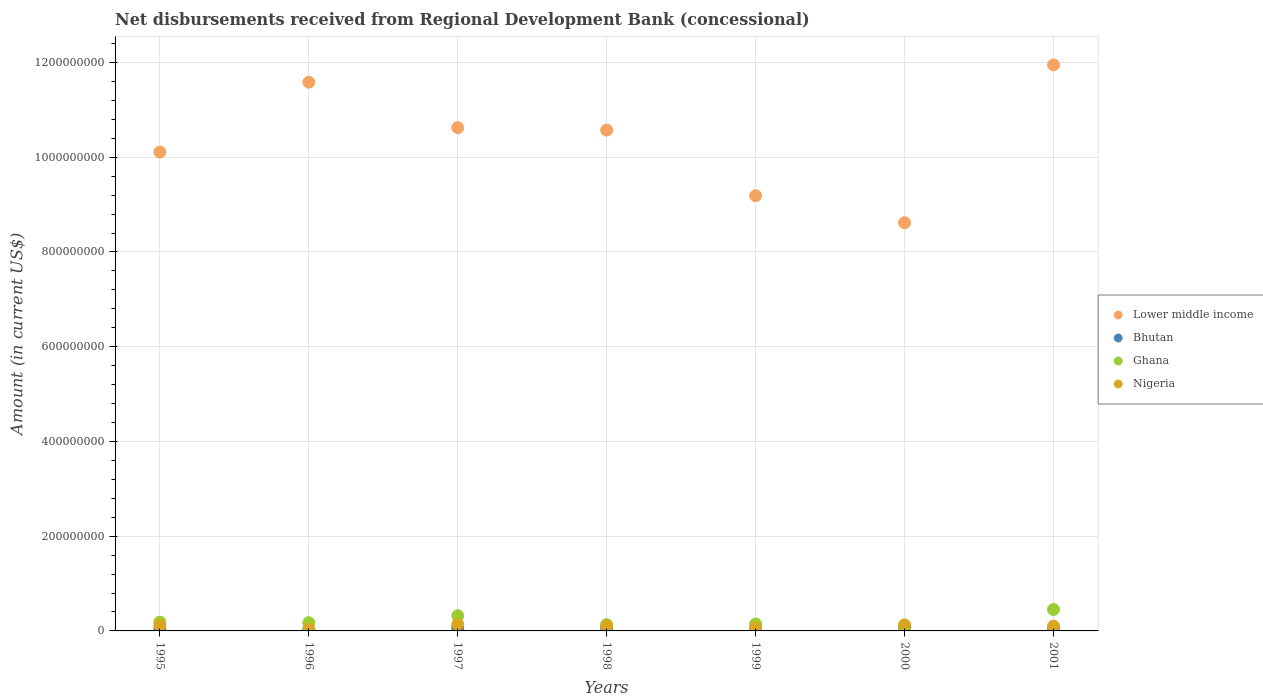How many different coloured dotlines are there?
Make the answer very short. 4. What is the amount of disbursements received from Regional Development Bank in Bhutan in 1998?
Ensure brevity in your answer.  3.78e+06. Across all years, what is the maximum amount of disbursements received from Regional Development Bank in Lower middle income?
Give a very brief answer. 1.20e+09. Across all years, what is the minimum amount of disbursements received from Regional Development Bank in Bhutan?
Your answer should be very brief. 1.33e+06. What is the total amount of disbursements received from Regional Development Bank in Lower middle income in the graph?
Your response must be concise. 7.26e+09. What is the difference between the amount of disbursements received from Regional Development Bank in Ghana in 1995 and that in 2001?
Provide a short and direct response. -2.66e+07. What is the difference between the amount of disbursements received from Regional Development Bank in Ghana in 1995 and the amount of disbursements received from Regional Development Bank in Bhutan in 2001?
Your answer should be very brief. 1.26e+07. What is the average amount of disbursements received from Regional Development Bank in Ghana per year?
Offer a very short reply. 2.03e+07. In the year 1999, what is the difference between the amount of disbursements received from Regional Development Bank in Lower middle income and amount of disbursements received from Regional Development Bank in Nigeria?
Your response must be concise. 9.12e+08. In how many years, is the amount of disbursements received from Regional Development Bank in Nigeria greater than 280000000 US$?
Give a very brief answer. 0. What is the ratio of the amount of disbursements received from Regional Development Bank in Lower middle income in 1997 to that in 1998?
Your response must be concise. 1. What is the difference between the highest and the second highest amount of disbursements received from Regional Development Bank in Lower middle income?
Keep it short and to the point. 3.65e+07. What is the difference between the highest and the lowest amount of disbursements received from Regional Development Bank in Bhutan?
Give a very brief answer. 5.35e+06. In how many years, is the amount of disbursements received from Regional Development Bank in Bhutan greater than the average amount of disbursements received from Regional Development Bank in Bhutan taken over all years?
Your response must be concise. 3. Is the amount of disbursements received from Regional Development Bank in Lower middle income strictly greater than the amount of disbursements received from Regional Development Bank in Ghana over the years?
Offer a terse response. Yes. Does the graph contain grids?
Your response must be concise. Yes. Where does the legend appear in the graph?
Your answer should be compact. Center right. What is the title of the graph?
Keep it short and to the point. Net disbursements received from Regional Development Bank (concessional). Does "Bhutan" appear as one of the legend labels in the graph?
Keep it short and to the point. Yes. What is the label or title of the X-axis?
Give a very brief answer. Years. What is the Amount (in current US$) in Lower middle income in 1995?
Make the answer very short. 1.01e+09. What is the Amount (in current US$) in Bhutan in 1995?
Offer a terse response. 3.21e+06. What is the Amount (in current US$) in Ghana in 1995?
Give a very brief answer. 1.87e+07. What is the Amount (in current US$) in Nigeria in 1995?
Provide a succinct answer. 1.16e+07. What is the Amount (in current US$) of Lower middle income in 1996?
Provide a succinct answer. 1.16e+09. What is the Amount (in current US$) of Bhutan in 1996?
Make the answer very short. 2.41e+06. What is the Amount (in current US$) in Ghana in 1996?
Provide a short and direct response. 1.74e+07. What is the Amount (in current US$) of Nigeria in 1996?
Provide a short and direct response. 3.98e+06. What is the Amount (in current US$) in Lower middle income in 1997?
Your answer should be compact. 1.06e+09. What is the Amount (in current US$) of Bhutan in 1997?
Offer a terse response. 6.68e+06. What is the Amount (in current US$) of Ghana in 1997?
Ensure brevity in your answer.  3.21e+07. What is the Amount (in current US$) of Nigeria in 1997?
Offer a very short reply. 1.39e+07. What is the Amount (in current US$) in Lower middle income in 1998?
Provide a succinct answer. 1.06e+09. What is the Amount (in current US$) in Bhutan in 1998?
Make the answer very short. 3.78e+06. What is the Amount (in current US$) of Ghana in 1998?
Make the answer very short. 1.32e+07. What is the Amount (in current US$) of Nigeria in 1998?
Provide a succinct answer. 9.97e+06. What is the Amount (in current US$) of Lower middle income in 1999?
Offer a very short reply. 9.19e+08. What is the Amount (in current US$) in Bhutan in 1999?
Your answer should be compact. 1.33e+06. What is the Amount (in current US$) of Ghana in 1999?
Provide a succinct answer. 1.46e+07. What is the Amount (in current US$) in Nigeria in 1999?
Give a very brief answer. 6.28e+06. What is the Amount (in current US$) in Lower middle income in 2000?
Offer a terse response. 8.62e+08. What is the Amount (in current US$) in Bhutan in 2000?
Offer a very short reply. 6.14e+06. What is the Amount (in current US$) of Ghana in 2000?
Your answer should be very brief. 7.06e+05. What is the Amount (in current US$) of Nigeria in 2000?
Give a very brief answer. 1.27e+07. What is the Amount (in current US$) of Lower middle income in 2001?
Give a very brief answer. 1.20e+09. What is the Amount (in current US$) in Bhutan in 2001?
Your answer should be compact. 6.04e+06. What is the Amount (in current US$) of Ghana in 2001?
Give a very brief answer. 4.53e+07. What is the Amount (in current US$) of Nigeria in 2001?
Your answer should be very brief. 1.01e+07. Across all years, what is the maximum Amount (in current US$) of Lower middle income?
Offer a terse response. 1.20e+09. Across all years, what is the maximum Amount (in current US$) of Bhutan?
Your answer should be compact. 6.68e+06. Across all years, what is the maximum Amount (in current US$) in Ghana?
Offer a very short reply. 4.53e+07. Across all years, what is the maximum Amount (in current US$) in Nigeria?
Ensure brevity in your answer.  1.39e+07. Across all years, what is the minimum Amount (in current US$) in Lower middle income?
Provide a short and direct response. 8.62e+08. Across all years, what is the minimum Amount (in current US$) in Bhutan?
Make the answer very short. 1.33e+06. Across all years, what is the minimum Amount (in current US$) in Ghana?
Offer a terse response. 7.06e+05. Across all years, what is the minimum Amount (in current US$) of Nigeria?
Provide a succinct answer. 3.98e+06. What is the total Amount (in current US$) of Lower middle income in the graph?
Your answer should be very brief. 7.26e+09. What is the total Amount (in current US$) in Bhutan in the graph?
Keep it short and to the point. 2.96e+07. What is the total Amount (in current US$) in Ghana in the graph?
Offer a terse response. 1.42e+08. What is the total Amount (in current US$) of Nigeria in the graph?
Your answer should be compact. 6.86e+07. What is the difference between the Amount (in current US$) in Lower middle income in 1995 and that in 1996?
Provide a short and direct response. -1.47e+08. What is the difference between the Amount (in current US$) in Ghana in 1995 and that in 1996?
Provide a short and direct response. 1.25e+06. What is the difference between the Amount (in current US$) in Nigeria in 1995 and that in 1996?
Ensure brevity in your answer.  7.66e+06. What is the difference between the Amount (in current US$) of Lower middle income in 1995 and that in 1997?
Ensure brevity in your answer.  -5.14e+07. What is the difference between the Amount (in current US$) of Bhutan in 1995 and that in 1997?
Ensure brevity in your answer.  -3.47e+06. What is the difference between the Amount (in current US$) of Ghana in 1995 and that in 1997?
Offer a very short reply. -1.34e+07. What is the difference between the Amount (in current US$) in Nigeria in 1995 and that in 1997?
Give a very brief answer. -2.25e+06. What is the difference between the Amount (in current US$) in Lower middle income in 1995 and that in 1998?
Keep it short and to the point. -4.63e+07. What is the difference between the Amount (in current US$) in Bhutan in 1995 and that in 1998?
Your response must be concise. -5.66e+05. What is the difference between the Amount (in current US$) in Ghana in 1995 and that in 1998?
Offer a very short reply. 5.48e+06. What is the difference between the Amount (in current US$) of Nigeria in 1995 and that in 1998?
Your answer should be compact. 1.67e+06. What is the difference between the Amount (in current US$) of Lower middle income in 1995 and that in 1999?
Make the answer very short. 9.23e+07. What is the difference between the Amount (in current US$) in Bhutan in 1995 and that in 1999?
Offer a terse response. 1.88e+06. What is the difference between the Amount (in current US$) of Ghana in 1995 and that in 1999?
Provide a succinct answer. 4.10e+06. What is the difference between the Amount (in current US$) of Nigeria in 1995 and that in 1999?
Provide a succinct answer. 5.37e+06. What is the difference between the Amount (in current US$) in Lower middle income in 1995 and that in 2000?
Offer a terse response. 1.49e+08. What is the difference between the Amount (in current US$) in Bhutan in 1995 and that in 2000?
Keep it short and to the point. -2.93e+06. What is the difference between the Amount (in current US$) in Ghana in 1995 and that in 2000?
Provide a succinct answer. 1.80e+07. What is the difference between the Amount (in current US$) in Nigeria in 1995 and that in 2000?
Ensure brevity in your answer.  -1.09e+06. What is the difference between the Amount (in current US$) of Lower middle income in 1995 and that in 2001?
Offer a terse response. -1.84e+08. What is the difference between the Amount (in current US$) of Bhutan in 1995 and that in 2001?
Your response must be concise. -2.83e+06. What is the difference between the Amount (in current US$) in Ghana in 1995 and that in 2001?
Your response must be concise. -2.66e+07. What is the difference between the Amount (in current US$) of Nigeria in 1995 and that in 2001?
Offer a terse response. 1.52e+06. What is the difference between the Amount (in current US$) of Lower middle income in 1996 and that in 1997?
Provide a short and direct response. 9.60e+07. What is the difference between the Amount (in current US$) of Bhutan in 1996 and that in 1997?
Offer a very short reply. -4.27e+06. What is the difference between the Amount (in current US$) in Ghana in 1996 and that in 1997?
Give a very brief answer. -1.47e+07. What is the difference between the Amount (in current US$) of Nigeria in 1996 and that in 1997?
Make the answer very short. -9.91e+06. What is the difference between the Amount (in current US$) of Lower middle income in 1996 and that in 1998?
Your response must be concise. 1.01e+08. What is the difference between the Amount (in current US$) in Bhutan in 1996 and that in 1998?
Make the answer very short. -1.37e+06. What is the difference between the Amount (in current US$) in Ghana in 1996 and that in 1998?
Your response must be concise. 4.23e+06. What is the difference between the Amount (in current US$) of Nigeria in 1996 and that in 1998?
Your answer should be very brief. -5.99e+06. What is the difference between the Amount (in current US$) in Lower middle income in 1996 and that in 1999?
Provide a short and direct response. 2.40e+08. What is the difference between the Amount (in current US$) of Bhutan in 1996 and that in 1999?
Offer a very short reply. 1.08e+06. What is the difference between the Amount (in current US$) in Ghana in 1996 and that in 1999?
Give a very brief answer. 2.84e+06. What is the difference between the Amount (in current US$) of Nigeria in 1996 and that in 1999?
Offer a very short reply. -2.29e+06. What is the difference between the Amount (in current US$) in Lower middle income in 1996 and that in 2000?
Make the answer very short. 2.97e+08. What is the difference between the Amount (in current US$) in Bhutan in 1996 and that in 2000?
Ensure brevity in your answer.  -3.73e+06. What is the difference between the Amount (in current US$) in Ghana in 1996 and that in 2000?
Give a very brief answer. 1.67e+07. What is the difference between the Amount (in current US$) of Nigeria in 1996 and that in 2000?
Ensure brevity in your answer.  -8.75e+06. What is the difference between the Amount (in current US$) of Lower middle income in 1996 and that in 2001?
Keep it short and to the point. -3.65e+07. What is the difference between the Amount (in current US$) in Bhutan in 1996 and that in 2001?
Your response must be concise. -3.63e+06. What is the difference between the Amount (in current US$) of Ghana in 1996 and that in 2001?
Ensure brevity in your answer.  -2.79e+07. What is the difference between the Amount (in current US$) in Nigeria in 1996 and that in 2001?
Keep it short and to the point. -6.13e+06. What is the difference between the Amount (in current US$) of Lower middle income in 1997 and that in 1998?
Ensure brevity in your answer.  5.16e+06. What is the difference between the Amount (in current US$) in Bhutan in 1997 and that in 1998?
Your response must be concise. 2.90e+06. What is the difference between the Amount (in current US$) in Ghana in 1997 and that in 1998?
Give a very brief answer. 1.89e+07. What is the difference between the Amount (in current US$) in Nigeria in 1997 and that in 1998?
Offer a very short reply. 3.92e+06. What is the difference between the Amount (in current US$) of Lower middle income in 1997 and that in 1999?
Your answer should be compact. 1.44e+08. What is the difference between the Amount (in current US$) in Bhutan in 1997 and that in 1999?
Offer a terse response. 5.35e+06. What is the difference between the Amount (in current US$) of Ghana in 1997 and that in 1999?
Keep it short and to the point. 1.75e+07. What is the difference between the Amount (in current US$) of Nigeria in 1997 and that in 1999?
Make the answer very short. 7.62e+06. What is the difference between the Amount (in current US$) of Lower middle income in 1997 and that in 2000?
Make the answer very short. 2.01e+08. What is the difference between the Amount (in current US$) in Bhutan in 1997 and that in 2000?
Your response must be concise. 5.43e+05. What is the difference between the Amount (in current US$) in Ghana in 1997 and that in 2000?
Give a very brief answer. 3.14e+07. What is the difference between the Amount (in current US$) of Nigeria in 1997 and that in 2000?
Your answer should be very brief. 1.16e+06. What is the difference between the Amount (in current US$) of Lower middle income in 1997 and that in 2001?
Offer a very short reply. -1.33e+08. What is the difference between the Amount (in current US$) of Bhutan in 1997 and that in 2001?
Provide a succinct answer. 6.40e+05. What is the difference between the Amount (in current US$) in Ghana in 1997 and that in 2001?
Your answer should be compact. -1.32e+07. What is the difference between the Amount (in current US$) of Nigeria in 1997 and that in 2001?
Give a very brief answer. 3.78e+06. What is the difference between the Amount (in current US$) of Lower middle income in 1998 and that in 1999?
Offer a terse response. 1.39e+08. What is the difference between the Amount (in current US$) of Bhutan in 1998 and that in 1999?
Keep it short and to the point. 2.45e+06. What is the difference between the Amount (in current US$) of Ghana in 1998 and that in 1999?
Give a very brief answer. -1.38e+06. What is the difference between the Amount (in current US$) in Nigeria in 1998 and that in 1999?
Your answer should be compact. 3.70e+06. What is the difference between the Amount (in current US$) of Lower middle income in 1998 and that in 2000?
Offer a very short reply. 1.96e+08. What is the difference between the Amount (in current US$) of Bhutan in 1998 and that in 2000?
Offer a very short reply. -2.36e+06. What is the difference between the Amount (in current US$) of Ghana in 1998 and that in 2000?
Give a very brief answer. 1.25e+07. What is the difference between the Amount (in current US$) in Nigeria in 1998 and that in 2000?
Provide a succinct answer. -2.76e+06. What is the difference between the Amount (in current US$) of Lower middle income in 1998 and that in 2001?
Provide a succinct answer. -1.38e+08. What is the difference between the Amount (in current US$) in Bhutan in 1998 and that in 2001?
Your answer should be compact. -2.26e+06. What is the difference between the Amount (in current US$) in Ghana in 1998 and that in 2001?
Give a very brief answer. -3.21e+07. What is the difference between the Amount (in current US$) of Nigeria in 1998 and that in 2001?
Your answer should be compact. -1.47e+05. What is the difference between the Amount (in current US$) of Lower middle income in 1999 and that in 2000?
Provide a short and direct response. 5.71e+07. What is the difference between the Amount (in current US$) of Bhutan in 1999 and that in 2000?
Make the answer very short. -4.81e+06. What is the difference between the Amount (in current US$) of Ghana in 1999 and that in 2000?
Give a very brief answer. 1.39e+07. What is the difference between the Amount (in current US$) of Nigeria in 1999 and that in 2000?
Your answer should be very brief. -6.46e+06. What is the difference between the Amount (in current US$) of Lower middle income in 1999 and that in 2001?
Your response must be concise. -2.76e+08. What is the difference between the Amount (in current US$) of Bhutan in 1999 and that in 2001?
Provide a succinct answer. -4.71e+06. What is the difference between the Amount (in current US$) of Ghana in 1999 and that in 2001?
Offer a very short reply. -3.07e+07. What is the difference between the Amount (in current US$) of Nigeria in 1999 and that in 2001?
Ensure brevity in your answer.  -3.84e+06. What is the difference between the Amount (in current US$) in Lower middle income in 2000 and that in 2001?
Keep it short and to the point. -3.33e+08. What is the difference between the Amount (in current US$) in Bhutan in 2000 and that in 2001?
Keep it short and to the point. 9.70e+04. What is the difference between the Amount (in current US$) in Ghana in 2000 and that in 2001?
Offer a very short reply. -4.46e+07. What is the difference between the Amount (in current US$) of Nigeria in 2000 and that in 2001?
Your answer should be compact. 2.62e+06. What is the difference between the Amount (in current US$) of Lower middle income in 1995 and the Amount (in current US$) of Bhutan in 1996?
Provide a short and direct response. 1.01e+09. What is the difference between the Amount (in current US$) of Lower middle income in 1995 and the Amount (in current US$) of Ghana in 1996?
Provide a short and direct response. 9.94e+08. What is the difference between the Amount (in current US$) of Lower middle income in 1995 and the Amount (in current US$) of Nigeria in 1996?
Provide a short and direct response. 1.01e+09. What is the difference between the Amount (in current US$) in Bhutan in 1995 and the Amount (in current US$) in Ghana in 1996?
Your answer should be compact. -1.42e+07. What is the difference between the Amount (in current US$) of Bhutan in 1995 and the Amount (in current US$) of Nigeria in 1996?
Provide a succinct answer. -7.71e+05. What is the difference between the Amount (in current US$) in Ghana in 1995 and the Amount (in current US$) in Nigeria in 1996?
Give a very brief answer. 1.47e+07. What is the difference between the Amount (in current US$) in Lower middle income in 1995 and the Amount (in current US$) in Bhutan in 1997?
Keep it short and to the point. 1.00e+09. What is the difference between the Amount (in current US$) in Lower middle income in 1995 and the Amount (in current US$) in Ghana in 1997?
Keep it short and to the point. 9.79e+08. What is the difference between the Amount (in current US$) of Lower middle income in 1995 and the Amount (in current US$) of Nigeria in 1997?
Your response must be concise. 9.97e+08. What is the difference between the Amount (in current US$) of Bhutan in 1995 and the Amount (in current US$) of Ghana in 1997?
Your answer should be very brief. -2.89e+07. What is the difference between the Amount (in current US$) of Bhutan in 1995 and the Amount (in current US$) of Nigeria in 1997?
Make the answer very short. -1.07e+07. What is the difference between the Amount (in current US$) in Ghana in 1995 and the Amount (in current US$) in Nigeria in 1997?
Make the answer very short. 4.76e+06. What is the difference between the Amount (in current US$) in Lower middle income in 1995 and the Amount (in current US$) in Bhutan in 1998?
Provide a succinct answer. 1.01e+09. What is the difference between the Amount (in current US$) of Lower middle income in 1995 and the Amount (in current US$) of Ghana in 1998?
Give a very brief answer. 9.98e+08. What is the difference between the Amount (in current US$) of Lower middle income in 1995 and the Amount (in current US$) of Nigeria in 1998?
Give a very brief answer. 1.00e+09. What is the difference between the Amount (in current US$) in Bhutan in 1995 and the Amount (in current US$) in Ghana in 1998?
Give a very brief answer. -9.96e+06. What is the difference between the Amount (in current US$) of Bhutan in 1995 and the Amount (in current US$) of Nigeria in 1998?
Ensure brevity in your answer.  -6.76e+06. What is the difference between the Amount (in current US$) in Ghana in 1995 and the Amount (in current US$) in Nigeria in 1998?
Your response must be concise. 8.69e+06. What is the difference between the Amount (in current US$) of Lower middle income in 1995 and the Amount (in current US$) of Bhutan in 1999?
Offer a terse response. 1.01e+09. What is the difference between the Amount (in current US$) in Lower middle income in 1995 and the Amount (in current US$) in Ghana in 1999?
Make the answer very short. 9.96e+08. What is the difference between the Amount (in current US$) in Lower middle income in 1995 and the Amount (in current US$) in Nigeria in 1999?
Your response must be concise. 1.00e+09. What is the difference between the Amount (in current US$) in Bhutan in 1995 and the Amount (in current US$) in Ghana in 1999?
Your response must be concise. -1.13e+07. What is the difference between the Amount (in current US$) of Bhutan in 1995 and the Amount (in current US$) of Nigeria in 1999?
Provide a succinct answer. -3.06e+06. What is the difference between the Amount (in current US$) of Ghana in 1995 and the Amount (in current US$) of Nigeria in 1999?
Keep it short and to the point. 1.24e+07. What is the difference between the Amount (in current US$) of Lower middle income in 1995 and the Amount (in current US$) of Bhutan in 2000?
Make the answer very short. 1.00e+09. What is the difference between the Amount (in current US$) in Lower middle income in 1995 and the Amount (in current US$) in Ghana in 2000?
Give a very brief answer. 1.01e+09. What is the difference between the Amount (in current US$) in Lower middle income in 1995 and the Amount (in current US$) in Nigeria in 2000?
Provide a succinct answer. 9.98e+08. What is the difference between the Amount (in current US$) of Bhutan in 1995 and the Amount (in current US$) of Ghana in 2000?
Your answer should be compact. 2.51e+06. What is the difference between the Amount (in current US$) of Bhutan in 1995 and the Amount (in current US$) of Nigeria in 2000?
Provide a short and direct response. -9.52e+06. What is the difference between the Amount (in current US$) of Ghana in 1995 and the Amount (in current US$) of Nigeria in 2000?
Keep it short and to the point. 5.92e+06. What is the difference between the Amount (in current US$) in Lower middle income in 1995 and the Amount (in current US$) in Bhutan in 2001?
Keep it short and to the point. 1.00e+09. What is the difference between the Amount (in current US$) of Lower middle income in 1995 and the Amount (in current US$) of Ghana in 2001?
Give a very brief answer. 9.66e+08. What is the difference between the Amount (in current US$) in Lower middle income in 1995 and the Amount (in current US$) in Nigeria in 2001?
Make the answer very short. 1.00e+09. What is the difference between the Amount (in current US$) in Bhutan in 1995 and the Amount (in current US$) in Ghana in 2001?
Keep it short and to the point. -4.21e+07. What is the difference between the Amount (in current US$) of Bhutan in 1995 and the Amount (in current US$) of Nigeria in 2001?
Give a very brief answer. -6.90e+06. What is the difference between the Amount (in current US$) in Ghana in 1995 and the Amount (in current US$) in Nigeria in 2001?
Your response must be concise. 8.54e+06. What is the difference between the Amount (in current US$) in Lower middle income in 1996 and the Amount (in current US$) in Bhutan in 1997?
Ensure brevity in your answer.  1.15e+09. What is the difference between the Amount (in current US$) in Lower middle income in 1996 and the Amount (in current US$) in Ghana in 1997?
Your response must be concise. 1.13e+09. What is the difference between the Amount (in current US$) in Lower middle income in 1996 and the Amount (in current US$) in Nigeria in 1997?
Make the answer very short. 1.14e+09. What is the difference between the Amount (in current US$) of Bhutan in 1996 and the Amount (in current US$) of Ghana in 1997?
Give a very brief answer. -2.97e+07. What is the difference between the Amount (in current US$) of Bhutan in 1996 and the Amount (in current US$) of Nigeria in 1997?
Give a very brief answer. -1.15e+07. What is the difference between the Amount (in current US$) in Ghana in 1996 and the Amount (in current US$) in Nigeria in 1997?
Give a very brief answer. 3.51e+06. What is the difference between the Amount (in current US$) of Lower middle income in 1996 and the Amount (in current US$) of Bhutan in 1998?
Your answer should be very brief. 1.15e+09. What is the difference between the Amount (in current US$) in Lower middle income in 1996 and the Amount (in current US$) in Ghana in 1998?
Offer a very short reply. 1.15e+09. What is the difference between the Amount (in current US$) in Lower middle income in 1996 and the Amount (in current US$) in Nigeria in 1998?
Provide a short and direct response. 1.15e+09. What is the difference between the Amount (in current US$) in Bhutan in 1996 and the Amount (in current US$) in Ghana in 1998?
Provide a succinct answer. -1.08e+07. What is the difference between the Amount (in current US$) in Bhutan in 1996 and the Amount (in current US$) in Nigeria in 1998?
Offer a terse response. -7.56e+06. What is the difference between the Amount (in current US$) in Ghana in 1996 and the Amount (in current US$) in Nigeria in 1998?
Provide a short and direct response. 7.43e+06. What is the difference between the Amount (in current US$) of Lower middle income in 1996 and the Amount (in current US$) of Bhutan in 1999?
Give a very brief answer. 1.16e+09. What is the difference between the Amount (in current US$) of Lower middle income in 1996 and the Amount (in current US$) of Ghana in 1999?
Offer a terse response. 1.14e+09. What is the difference between the Amount (in current US$) in Lower middle income in 1996 and the Amount (in current US$) in Nigeria in 1999?
Make the answer very short. 1.15e+09. What is the difference between the Amount (in current US$) of Bhutan in 1996 and the Amount (in current US$) of Ghana in 1999?
Give a very brief answer. -1.21e+07. What is the difference between the Amount (in current US$) of Bhutan in 1996 and the Amount (in current US$) of Nigeria in 1999?
Your answer should be very brief. -3.86e+06. What is the difference between the Amount (in current US$) in Ghana in 1996 and the Amount (in current US$) in Nigeria in 1999?
Give a very brief answer. 1.11e+07. What is the difference between the Amount (in current US$) in Lower middle income in 1996 and the Amount (in current US$) in Bhutan in 2000?
Make the answer very short. 1.15e+09. What is the difference between the Amount (in current US$) in Lower middle income in 1996 and the Amount (in current US$) in Ghana in 2000?
Provide a succinct answer. 1.16e+09. What is the difference between the Amount (in current US$) in Lower middle income in 1996 and the Amount (in current US$) in Nigeria in 2000?
Your answer should be compact. 1.15e+09. What is the difference between the Amount (in current US$) in Bhutan in 1996 and the Amount (in current US$) in Ghana in 2000?
Offer a very short reply. 1.71e+06. What is the difference between the Amount (in current US$) of Bhutan in 1996 and the Amount (in current US$) of Nigeria in 2000?
Your response must be concise. -1.03e+07. What is the difference between the Amount (in current US$) in Ghana in 1996 and the Amount (in current US$) in Nigeria in 2000?
Your answer should be very brief. 4.67e+06. What is the difference between the Amount (in current US$) of Lower middle income in 1996 and the Amount (in current US$) of Bhutan in 2001?
Your answer should be compact. 1.15e+09. What is the difference between the Amount (in current US$) of Lower middle income in 1996 and the Amount (in current US$) of Ghana in 2001?
Provide a short and direct response. 1.11e+09. What is the difference between the Amount (in current US$) in Lower middle income in 1996 and the Amount (in current US$) in Nigeria in 2001?
Ensure brevity in your answer.  1.15e+09. What is the difference between the Amount (in current US$) in Bhutan in 1996 and the Amount (in current US$) in Ghana in 2001?
Provide a short and direct response. -4.29e+07. What is the difference between the Amount (in current US$) of Bhutan in 1996 and the Amount (in current US$) of Nigeria in 2001?
Your response must be concise. -7.70e+06. What is the difference between the Amount (in current US$) of Ghana in 1996 and the Amount (in current US$) of Nigeria in 2001?
Give a very brief answer. 7.29e+06. What is the difference between the Amount (in current US$) of Lower middle income in 1997 and the Amount (in current US$) of Bhutan in 1998?
Provide a succinct answer. 1.06e+09. What is the difference between the Amount (in current US$) of Lower middle income in 1997 and the Amount (in current US$) of Ghana in 1998?
Keep it short and to the point. 1.05e+09. What is the difference between the Amount (in current US$) in Lower middle income in 1997 and the Amount (in current US$) in Nigeria in 1998?
Ensure brevity in your answer.  1.05e+09. What is the difference between the Amount (in current US$) of Bhutan in 1997 and the Amount (in current US$) of Ghana in 1998?
Give a very brief answer. -6.49e+06. What is the difference between the Amount (in current US$) of Bhutan in 1997 and the Amount (in current US$) of Nigeria in 1998?
Make the answer very short. -3.29e+06. What is the difference between the Amount (in current US$) of Ghana in 1997 and the Amount (in current US$) of Nigeria in 1998?
Offer a terse response. 2.21e+07. What is the difference between the Amount (in current US$) of Lower middle income in 1997 and the Amount (in current US$) of Bhutan in 1999?
Your answer should be very brief. 1.06e+09. What is the difference between the Amount (in current US$) of Lower middle income in 1997 and the Amount (in current US$) of Ghana in 1999?
Provide a short and direct response. 1.05e+09. What is the difference between the Amount (in current US$) of Lower middle income in 1997 and the Amount (in current US$) of Nigeria in 1999?
Offer a terse response. 1.06e+09. What is the difference between the Amount (in current US$) of Bhutan in 1997 and the Amount (in current US$) of Ghana in 1999?
Offer a terse response. -7.88e+06. What is the difference between the Amount (in current US$) in Bhutan in 1997 and the Amount (in current US$) in Nigeria in 1999?
Provide a succinct answer. 4.06e+05. What is the difference between the Amount (in current US$) in Ghana in 1997 and the Amount (in current US$) in Nigeria in 1999?
Your answer should be compact. 2.58e+07. What is the difference between the Amount (in current US$) in Lower middle income in 1997 and the Amount (in current US$) in Bhutan in 2000?
Offer a very short reply. 1.06e+09. What is the difference between the Amount (in current US$) of Lower middle income in 1997 and the Amount (in current US$) of Ghana in 2000?
Keep it short and to the point. 1.06e+09. What is the difference between the Amount (in current US$) of Lower middle income in 1997 and the Amount (in current US$) of Nigeria in 2000?
Ensure brevity in your answer.  1.05e+09. What is the difference between the Amount (in current US$) of Bhutan in 1997 and the Amount (in current US$) of Ghana in 2000?
Keep it short and to the point. 5.98e+06. What is the difference between the Amount (in current US$) of Bhutan in 1997 and the Amount (in current US$) of Nigeria in 2000?
Offer a very short reply. -6.05e+06. What is the difference between the Amount (in current US$) in Ghana in 1997 and the Amount (in current US$) in Nigeria in 2000?
Ensure brevity in your answer.  1.93e+07. What is the difference between the Amount (in current US$) of Lower middle income in 1997 and the Amount (in current US$) of Bhutan in 2001?
Provide a succinct answer. 1.06e+09. What is the difference between the Amount (in current US$) in Lower middle income in 1997 and the Amount (in current US$) in Ghana in 2001?
Your response must be concise. 1.02e+09. What is the difference between the Amount (in current US$) in Lower middle income in 1997 and the Amount (in current US$) in Nigeria in 2001?
Keep it short and to the point. 1.05e+09. What is the difference between the Amount (in current US$) of Bhutan in 1997 and the Amount (in current US$) of Ghana in 2001?
Provide a short and direct response. -3.86e+07. What is the difference between the Amount (in current US$) of Bhutan in 1997 and the Amount (in current US$) of Nigeria in 2001?
Keep it short and to the point. -3.44e+06. What is the difference between the Amount (in current US$) of Ghana in 1997 and the Amount (in current US$) of Nigeria in 2001?
Your answer should be compact. 2.20e+07. What is the difference between the Amount (in current US$) of Lower middle income in 1998 and the Amount (in current US$) of Bhutan in 1999?
Your answer should be very brief. 1.06e+09. What is the difference between the Amount (in current US$) in Lower middle income in 1998 and the Amount (in current US$) in Ghana in 1999?
Make the answer very short. 1.04e+09. What is the difference between the Amount (in current US$) in Lower middle income in 1998 and the Amount (in current US$) in Nigeria in 1999?
Provide a short and direct response. 1.05e+09. What is the difference between the Amount (in current US$) of Bhutan in 1998 and the Amount (in current US$) of Ghana in 1999?
Offer a very short reply. -1.08e+07. What is the difference between the Amount (in current US$) in Bhutan in 1998 and the Amount (in current US$) in Nigeria in 1999?
Your answer should be very brief. -2.50e+06. What is the difference between the Amount (in current US$) of Ghana in 1998 and the Amount (in current US$) of Nigeria in 1999?
Offer a very short reply. 6.90e+06. What is the difference between the Amount (in current US$) in Lower middle income in 1998 and the Amount (in current US$) in Bhutan in 2000?
Your answer should be compact. 1.05e+09. What is the difference between the Amount (in current US$) of Lower middle income in 1998 and the Amount (in current US$) of Ghana in 2000?
Offer a very short reply. 1.06e+09. What is the difference between the Amount (in current US$) of Lower middle income in 1998 and the Amount (in current US$) of Nigeria in 2000?
Give a very brief answer. 1.04e+09. What is the difference between the Amount (in current US$) of Bhutan in 1998 and the Amount (in current US$) of Ghana in 2000?
Make the answer very short. 3.07e+06. What is the difference between the Amount (in current US$) in Bhutan in 1998 and the Amount (in current US$) in Nigeria in 2000?
Provide a short and direct response. -8.96e+06. What is the difference between the Amount (in current US$) of Lower middle income in 1998 and the Amount (in current US$) of Bhutan in 2001?
Your answer should be very brief. 1.05e+09. What is the difference between the Amount (in current US$) of Lower middle income in 1998 and the Amount (in current US$) of Ghana in 2001?
Ensure brevity in your answer.  1.01e+09. What is the difference between the Amount (in current US$) in Lower middle income in 1998 and the Amount (in current US$) in Nigeria in 2001?
Ensure brevity in your answer.  1.05e+09. What is the difference between the Amount (in current US$) in Bhutan in 1998 and the Amount (in current US$) in Ghana in 2001?
Your answer should be compact. -4.15e+07. What is the difference between the Amount (in current US$) of Bhutan in 1998 and the Amount (in current US$) of Nigeria in 2001?
Ensure brevity in your answer.  -6.34e+06. What is the difference between the Amount (in current US$) in Ghana in 1998 and the Amount (in current US$) in Nigeria in 2001?
Your answer should be compact. 3.06e+06. What is the difference between the Amount (in current US$) in Lower middle income in 1999 and the Amount (in current US$) in Bhutan in 2000?
Ensure brevity in your answer.  9.13e+08. What is the difference between the Amount (in current US$) of Lower middle income in 1999 and the Amount (in current US$) of Ghana in 2000?
Your response must be concise. 9.18e+08. What is the difference between the Amount (in current US$) of Lower middle income in 1999 and the Amount (in current US$) of Nigeria in 2000?
Make the answer very short. 9.06e+08. What is the difference between the Amount (in current US$) in Bhutan in 1999 and the Amount (in current US$) in Ghana in 2000?
Ensure brevity in your answer.  6.27e+05. What is the difference between the Amount (in current US$) in Bhutan in 1999 and the Amount (in current US$) in Nigeria in 2000?
Your answer should be compact. -1.14e+07. What is the difference between the Amount (in current US$) of Ghana in 1999 and the Amount (in current US$) of Nigeria in 2000?
Offer a terse response. 1.82e+06. What is the difference between the Amount (in current US$) in Lower middle income in 1999 and the Amount (in current US$) in Bhutan in 2001?
Give a very brief answer. 9.13e+08. What is the difference between the Amount (in current US$) in Lower middle income in 1999 and the Amount (in current US$) in Ghana in 2001?
Provide a short and direct response. 8.73e+08. What is the difference between the Amount (in current US$) of Lower middle income in 1999 and the Amount (in current US$) of Nigeria in 2001?
Offer a very short reply. 9.09e+08. What is the difference between the Amount (in current US$) in Bhutan in 1999 and the Amount (in current US$) in Ghana in 2001?
Provide a short and direct response. -4.39e+07. What is the difference between the Amount (in current US$) in Bhutan in 1999 and the Amount (in current US$) in Nigeria in 2001?
Give a very brief answer. -8.79e+06. What is the difference between the Amount (in current US$) of Ghana in 1999 and the Amount (in current US$) of Nigeria in 2001?
Offer a terse response. 4.44e+06. What is the difference between the Amount (in current US$) in Lower middle income in 2000 and the Amount (in current US$) in Bhutan in 2001?
Provide a succinct answer. 8.56e+08. What is the difference between the Amount (in current US$) of Lower middle income in 2000 and the Amount (in current US$) of Ghana in 2001?
Offer a very short reply. 8.16e+08. What is the difference between the Amount (in current US$) in Lower middle income in 2000 and the Amount (in current US$) in Nigeria in 2001?
Make the answer very short. 8.52e+08. What is the difference between the Amount (in current US$) in Bhutan in 2000 and the Amount (in current US$) in Ghana in 2001?
Provide a succinct answer. -3.91e+07. What is the difference between the Amount (in current US$) in Bhutan in 2000 and the Amount (in current US$) in Nigeria in 2001?
Offer a very short reply. -3.98e+06. What is the difference between the Amount (in current US$) of Ghana in 2000 and the Amount (in current US$) of Nigeria in 2001?
Keep it short and to the point. -9.41e+06. What is the average Amount (in current US$) in Lower middle income per year?
Keep it short and to the point. 1.04e+09. What is the average Amount (in current US$) in Bhutan per year?
Provide a succinct answer. 4.23e+06. What is the average Amount (in current US$) in Ghana per year?
Offer a terse response. 2.03e+07. What is the average Amount (in current US$) in Nigeria per year?
Your response must be concise. 9.80e+06. In the year 1995, what is the difference between the Amount (in current US$) in Lower middle income and Amount (in current US$) in Bhutan?
Keep it short and to the point. 1.01e+09. In the year 1995, what is the difference between the Amount (in current US$) in Lower middle income and Amount (in current US$) in Ghana?
Ensure brevity in your answer.  9.92e+08. In the year 1995, what is the difference between the Amount (in current US$) of Lower middle income and Amount (in current US$) of Nigeria?
Make the answer very short. 9.99e+08. In the year 1995, what is the difference between the Amount (in current US$) of Bhutan and Amount (in current US$) of Ghana?
Offer a terse response. -1.54e+07. In the year 1995, what is the difference between the Amount (in current US$) in Bhutan and Amount (in current US$) in Nigeria?
Offer a terse response. -8.43e+06. In the year 1995, what is the difference between the Amount (in current US$) of Ghana and Amount (in current US$) of Nigeria?
Ensure brevity in your answer.  7.02e+06. In the year 1996, what is the difference between the Amount (in current US$) in Lower middle income and Amount (in current US$) in Bhutan?
Your response must be concise. 1.16e+09. In the year 1996, what is the difference between the Amount (in current US$) in Lower middle income and Amount (in current US$) in Ghana?
Keep it short and to the point. 1.14e+09. In the year 1996, what is the difference between the Amount (in current US$) of Lower middle income and Amount (in current US$) of Nigeria?
Ensure brevity in your answer.  1.15e+09. In the year 1996, what is the difference between the Amount (in current US$) in Bhutan and Amount (in current US$) in Ghana?
Offer a very short reply. -1.50e+07. In the year 1996, what is the difference between the Amount (in current US$) in Bhutan and Amount (in current US$) in Nigeria?
Your answer should be compact. -1.57e+06. In the year 1996, what is the difference between the Amount (in current US$) in Ghana and Amount (in current US$) in Nigeria?
Provide a short and direct response. 1.34e+07. In the year 1997, what is the difference between the Amount (in current US$) of Lower middle income and Amount (in current US$) of Bhutan?
Your answer should be very brief. 1.06e+09. In the year 1997, what is the difference between the Amount (in current US$) of Lower middle income and Amount (in current US$) of Ghana?
Provide a succinct answer. 1.03e+09. In the year 1997, what is the difference between the Amount (in current US$) in Lower middle income and Amount (in current US$) in Nigeria?
Provide a succinct answer. 1.05e+09. In the year 1997, what is the difference between the Amount (in current US$) of Bhutan and Amount (in current US$) of Ghana?
Give a very brief answer. -2.54e+07. In the year 1997, what is the difference between the Amount (in current US$) of Bhutan and Amount (in current US$) of Nigeria?
Make the answer very short. -7.21e+06. In the year 1997, what is the difference between the Amount (in current US$) in Ghana and Amount (in current US$) in Nigeria?
Keep it short and to the point. 1.82e+07. In the year 1998, what is the difference between the Amount (in current US$) of Lower middle income and Amount (in current US$) of Bhutan?
Give a very brief answer. 1.05e+09. In the year 1998, what is the difference between the Amount (in current US$) of Lower middle income and Amount (in current US$) of Ghana?
Offer a terse response. 1.04e+09. In the year 1998, what is the difference between the Amount (in current US$) of Lower middle income and Amount (in current US$) of Nigeria?
Offer a terse response. 1.05e+09. In the year 1998, what is the difference between the Amount (in current US$) of Bhutan and Amount (in current US$) of Ghana?
Provide a short and direct response. -9.40e+06. In the year 1998, what is the difference between the Amount (in current US$) in Bhutan and Amount (in current US$) in Nigeria?
Make the answer very short. -6.19e+06. In the year 1998, what is the difference between the Amount (in current US$) of Ghana and Amount (in current US$) of Nigeria?
Offer a terse response. 3.20e+06. In the year 1999, what is the difference between the Amount (in current US$) of Lower middle income and Amount (in current US$) of Bhutan?
Make the answer very short. 9.17e+08. In the year 1999, what is the difference between the Amount (in current US$) in Lower middle income and Amount (in current US$) in Ghana?
Make the answer very short. 9.04e+08. In the year 1999, what is the difference between the Amount (in current US$) of Lower middle income and Amount (in current US$) of Nigeria?
Give a very brief answer. 9.12e+08. In the year 1999, what is the difference between the Amount (in current US$) in Bhutan and Amount (in current US$) in Ghana?
Your answer should be compact. -1.32e+07. In the year 1999, what is the difference between the Amount (in current US$) of Bhutan and Amount (in current US$) of Nigeria?
Offer a terse response. -4.94e+06. In the year 1999, what is the difference between the Amount (in current US$) in Ghana and Amount (in current US$) in Nigeria?
Offer a very short reply. 8.28e+06. In the year 2000, what is the difference between the Amount (in current US$) of Lower middle income and Amount (in current US$) of Bhutan?
Your answer should be compact. 8.56e+08. In the year 2000, what is the difference between the Amount (in current US$) in Lower middle income and Amount (in current US$) in Ghana?
Make the answer very short. 8.61e+08. In the year 2000, what is the difference between the Amount (in current US$) of Lower middle income and Amount (in current US$) of Nigeria?
Your answer should be very brief. 8.49e+08. In the year 2000, what is the difference between the Amount (in current US$) of Bhutan and Amount (in current US$) of Ghana?
Offer a terse response. 5.43e+06. In the year 2000, what is the difference between the Amount (in current US$) in Bhutan and Amount (in current US$) in Nigeria?
Provide a short and direct response. -6.60e+06. In the year 2000, what is the difference between the Amount (in current US$) of Ghana and Amount (in current US$) of Nigeria?
Your response must be concise. -1.20e+07. In the year 2001, what is the difference between the Amount (in current US$) of Lower middle income and Amount (in current US$) of Bhutan?
Ensure brevity in your answer.  1.19e+09. In the year 2001, what is the difference between the Amount (in current US$) of Lower middle income and Amount (in current US$) of Ghana?
Your response must be concise. 1.15e+09. In the year 2001, what is the difference between the Amount (in current US$) of Lower middle income and Amount (in current US$) of Nigeria?
Offer a terse response. 1.18e+09. In the year 2001, what is the difference between the Amount (in current US$) in Bhutan and Amount (in current US$) in Ghana?
Offer a terse response. -3.92e+07. In the year 2001, what is the difference between the Amount (in current US$) of Bhutan and Amount (in current US$) of Nigeria?
Your answer should be compact. -4.08e+06. In the year 2001, what is the difference between the Amount (in current US$) in Ghana and Amount (in current US$) in Nigeria?
Give a very brief answer. 3.51e+07. What is the ratio of the Amount (in current US$) of Lower middle income in 1995 to that in 1996?
Ensure brevity in your answer.  0.87. What is the ratio of the Amount (in current US$) in Bhutan in 1995 to that in 1996?
Keep it short and to the point. 1.33. What is the ratio of the Amount (in current US$) of Ghana in 1995 to that in 1996?
Provide a succinct answer. 1.07. What is the ratio of the Amount (in current US$) in Nigeria in 1995 to that in 1996?
Give a very brief answer. 2.92. What is the ratio of the Amount (in current US$) of Lower middle income in 1995 to that in 1997?
Provide a short and direct response. 0.95. What is the ratio of the Amount (in current US$) in Bhutan in 1995 to that in 1997?
Provide a succinct answer. 0.48. What is the ratio of the Amount (in current US$) of Ghana in 1995 to that in 1997?
Your answer should be very brief. 0.58. What is the ratio of the Amount (in current US$) of Nigeria in 1995 to that in 1997?
Offer a very short reply. 0.84. What is the ratio of the Amount (in current US$) in Lower middle income in 1995 to that in 1998?
Give a very brief answer. 0.96. What is the ratio of the Amount (in current US$) in Bhutan in 1995 to that in 1998?
Give a very brief answer. 0.85. What is the ratio of the Amount (in current US$) in Ghana in 1995 to that in 1998?
Make the answer very short. 1.42. What is the ratio of the Amount (in current US$) in Nigeria in 1995 to that in 1998?
Your answer should be very brief. 1.17. What is the ratio of the Amount (in current US$) of Lower middle income in 1995 to that in 1999?
Your answer should be compact. 1.1. What is the ratio of the Amount (in current US$) in Bhutan in 1995 to that in 1999?
Provide a short and direct response. 2.41. What is the ratio of the Amount (in current US$) of Ghana in 1995 to that in 1999?
Give a very brief answer. 1.28. What is the ratio of the Amount (in current US$) in Nigeria in 1995 to that in 1999?
Your answer should be very brief. 1.85. What is the ratio of the Amount (in current US$) in Lower middle income in 1995 to that in 2000?
Make the answer very short. 1.17. What is the ratio of the Amount (in current US$) of Bhutan in 1995 to that in 2000?
Provide a short and direct response. 0.52. What is the ratio of the Amount (in current US$) of Ghana in 1995 to that in 2000?
Your response must be concise. 26.43. What is the ratio of the Amount (in current US$) in Nigeria in 1995 to that in 2000?
Your answer should be very brief. 0.91. What is the ratio of the Amount (in current US$) of Lower middle income in 1995 to that in 2001?
Your answer should be compact. 0.85. What is the ratio of the Amount (in current US$) in Bhutan in 1995 to that in 2001?
Your response must be concise. 0.53. What is the ratio of the Amount (in current US$) of Ghana in 1995 to that in 2001?
Ensure brevity in your answer.  0.41. What is the ratio of the Amount (in current US$) of Nigeria in 1995 to that in 2001?
Ensure brevity in your answer.  1.15. What is the ratio of the Amount (in current US$) of Lower middle income in 1996 to that in 1997?
Make the answer very short. 1.09. What is the ratio of the Amount (in current US$) in Bhutan in 1996 to that in 1997?
Make the answer very short. 0.36. What is the ratio of the Amount (in current US$) in Ghana in 1996 to that in 1997?
Ensure brevity in your answer.  0.54. What is the ratio of the Amount (in current US$) in Nigeria in 1996 to that in 1997?
Give a very brief answer. 0.29. What is the ratio of the Amount (in current US$) in Lower middle income in 1996 to that in 1998?
Your answer should be compact. 1.1. What is the ratio of the Amount (in current US$) in Bhutan in 1996 to that in 1998?
Give a very brief answer. 0.64. What is the ratio of the Amount (in current US$) of Ghana in 1996 to that in 1998?
Offer a terse response. 1.32. What is the ratio of the Amount (in current US$) in Nigeria in 1996 to that in 1998?
Your answer should be very brief. 0.4. What is the ratio of the Amount (in current US$) of Lower middle income in 1996 to that in 1999?
Offer a very short reply. 1.26. What is the ratio of the Amount (in current US$) in Bhutan in 1996 to that in 1999?
Ensure brevity in your answer.  1.81. What is the ratio of the Amount (in current US$) in Ghana in 1996 to that in 1999?
Give a very brief answer. 1.2. What is the ratio of the Amount (in current US$) in Nigeria in 1996 to that in 1999?
Offer a terse response. 0.63. What is the ratio of the Amount (in current US$) in Lower middle income in 1996 to that in 2000?
Provide a succinct answer. 1.34. What is the ratio of the Amount (in current US$) of Bhutan in 1996 to that in 2000?
Keep it short and to the point. 0.39. What is the ratio of the Amount (in current US$) of Ghana in 1996 to that in 2000?
Your response must be concise. 24.65. What is the ratio of the Amount (in current US$) of Nigeria in 1996 to that in 2000?
Provide a short and direct response. 0.31. What is the ratio of the Amount (in current US$) in Lower middle income in 1996 to that in 2001?
Make the answer very short. 0.97. What is the ratio of the Amount (in current US$) in Bhutan in 1996 to that in 2001?
Ensure brevity in your answer.  0.4. What is the ratio of the Amount (in current US$) of Ghana in 1996 to that in 2001?
Offer a very short reply. 0.38. What is the ratio of the Amount (in current US$) of Nigeria in 1996 to that in 2001?
Ensure brevity in your answer.  0.39. What is the ratio of the Amount (in current US$) in Lower middle income in 1997 to that in 1998?
Your response must be concise. 1. What is the ratio of the Amount (in current US$) in Bhutan in 1997 to that in 1998?
Your response must be concise. 1.77. What is the ratio of the Amount (in current US$) in Ghana in 1997 to that in 1998?
Make the answer very short. 2.43. What is the ratio of the Amount (in current US$) of Nigeria in 1997 to that in 1998?
Make the answer very short. 1.39. What is the ratio of the Amount (in current US$) of Lower middle income in 1997 to that in 1999?
Your answer should be compact. 1.16. What is the ratio of the Amount (in current US$) of Bhutan in 1997 to that in 1999?
Offer a terse response. 5.01. What is the ratio of the Amount (in current US$) of Ghana in 1997 to that in 1999?
Offer a terse response. 2.2. What is the ratio of the Amount (in current US$) of Nigeria in 1997 to that in 1999?
Provide a succinct answer. 2.21. What is the ratio of the Amount (in current US$) of Lower middle income in 1997 to that in 2000?
Make the answer very short. 1.23. What is the ratio of the Amount (in current US$) of Bhutan in 1997 to that in 2000?
Provide a succinct answer. 1.09. What is the ratio of the Amount (in current US$) of Ghana in 1997 to that in 2000?
Ensure brevity in your answer.  45.43. What is the ratio of the Amount (in current US$) in Nigeria in 1997 to that in 2000?
Your response must be concise. 1.09. What is the ratio of the Amount (in current US$) in Lower middle income in 1997 to that in 2001?
Provide a succinct answer. 0.89. What is the ratio of the Amount (in current US$) of Bhutan in 1997 to that in 2001?
Your answer should be compact. 1.11. What is the ratio of the Amount (in current US$) in Ghana in 1997 to that in 2001?
Provide a succinct answer. 0.71. What is the ratio of the Amount (in current US$) in Nigeria in 1997 to that in 2001?
Your response must be concise. 1.37. What is the ratio of the Amount (in current US$) in Lower middle income in 1998 to that in 1999?
Ensure brevity in your answer.  1.15. What is the ratio of the Amount (in current US$) in Bhutan in 1998 to that in 1999?
Your answer should be compact. 2.84. What is the ratio of the Amount (in current US$) in Ghana in 1998 to that in 1999?
Your response must be concise. 0.91. What is the ratio of the Amount (in current US$) of Nigeria in 1998 to that in 1999?
Your answer should be very brief. 1.59. What is the ratio of the Amount (in current US$) of Lower middle income in 1998 to that in 2000?
Offer a very short reply. 1.23. What is the ratio of the Amount (in current US$) in Bhutan in 1998 to that in 2000?
Provide a short and direct response. 0.62. What is the ratio of the Amount (in current US$) of Ghana in 1998 to that in 2000?
Ensure brevity in your answer.  18.66. What is the ratio of the Amount (in current US$) of Nigeria in 1998 to that in 2000?
Provide a succinct answer. 0.78. What is the ratio of the Amount (in current US$) of Lower middle income in 1998 to that in 2001?
Your response must be concise. 0.88. What is the ratio of the Amount (in current US$) of Bhutan in 1998 to that in 2001?
Make the answer very short. 0.63. What is the ratio of the Amount (in current US$) in Ghana in 1998 to that in 2001?
Give a very brief answer. 0.29. What is the ratio of the Amount (in current US$) of Nigeria in 1998 to that in 2001?
Offer a terse response. 0.99. What is the ratio of the Amount (in current US$) of Lower middle income in 1999 to that in 2000?
Ensure brevity in your answer.  1.07. What is the ratio of the Amount (in current US$) in Bhutan in 1999 to that in 2000?
Provide a succinct answer. 0.22. What is the ratio of the Amount (in current US$) in Ghana in 1999 to that in 2000?
Provide a succinct answer. 20.62. What is the ratio of the Amount (in current US$) in Nigeria in 1999 to that in 2000?
Provide a succinct answer. 0.49. What is the ratio of the Amount (in current US$) of Lower middle income in 1999 to that in 2001?
Your answer should be compact. 0.77. What is the ratio of the Amount (in current US$) in Bhutan in 1999 to that in 2001?
Provide a short and direct response. 0.22. What is the ratio of the Amount (in current US$) of Ghana in 1999 to that in 2001?
Keep it short and to the point. 0.32. What is the ratio of the Amount (in current US$) of Nigeria in 1999 to that in 2001?
Your answer should be compact. 0.62. What is the ratio of the Amount (in current US$) in Lower middle income in 2000 to that in 2001?
Your answer should be compact. 0.72. What is the ratio of the Amount (in current US$) of Bhutan in 2000 to that in 2001?
Offer a terse response. 1.02. What is the ratio of the Amount (in current US$) of Ghana in 2000 to that in 2001?
Give a very brief answer. 0.02. What is the ratio of the Amount (in current US$) in Nigeria in 2000 to that in 2001?
Your response must be concise. 1.26. What is the difference between the highest and the second highest Amount (in current US$) of Lower middle income?
Make the answer very short. 3.65e+07. What is the difference between the highest and the second highest Amount (in current US$) in Bhutan?
Your response must be concise. 5.43e+05. What is the difference between the highest and the second highest Amount (in current US$) in Ghana?
Offer a terse response. 1.32e+07. What is the difference between the highest and the second highest Amount (in current US$) in Nigeria?
Your answer should be very brief. 1.16e+06. What is the difference between the highest and the lowest Amount (in current US$) in Lower middle income?
Keep it short and to the point. 3.33e+08. What is the difference between the highest and the lowest Amount (in current US$) of Bhutan?
Give a very brief answer. 5.35e+06. What is the difference between the highest and the lowest Amount (in current US$) in Ghana?
Ensure brevity in your answer.  4.46e+07. What is the difference between the highest and the lowest Amount (in current US$) of Nigeria?
Provide a succinct answer. 9.91e+06. 